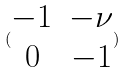Convert formula to latex. <formula><loc_0><loc_0><loc_500><loc_500>( \begin{matrix} - 1 & - \nu \\ 0 & - 1 \end{matrix} )</formula> 